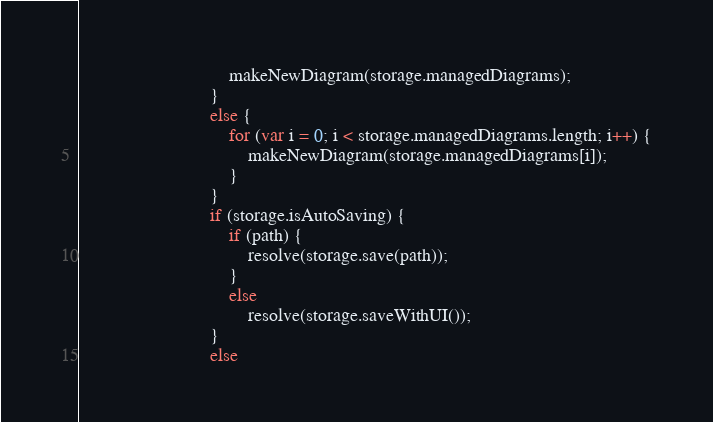<code> <loc_0><loc_0><loc_500><loc_500><_JavaScript_>                                makeNewDiagram(storage.managedDiagrams);
                            }
                            else {
                                for (var i = 0; i < storage.managedDiagrams.length; i++) {
                                    makeNewDiagram(storage.managedDiagrams[i]);
                                }
                            }
                            if (storage.isAutoSaving) {
                                if (path) {
                                    resolve(storage.save(path));
                                }
                                else
                                    resolve(storage.saveWithUI());
                            }
                            else</code> 